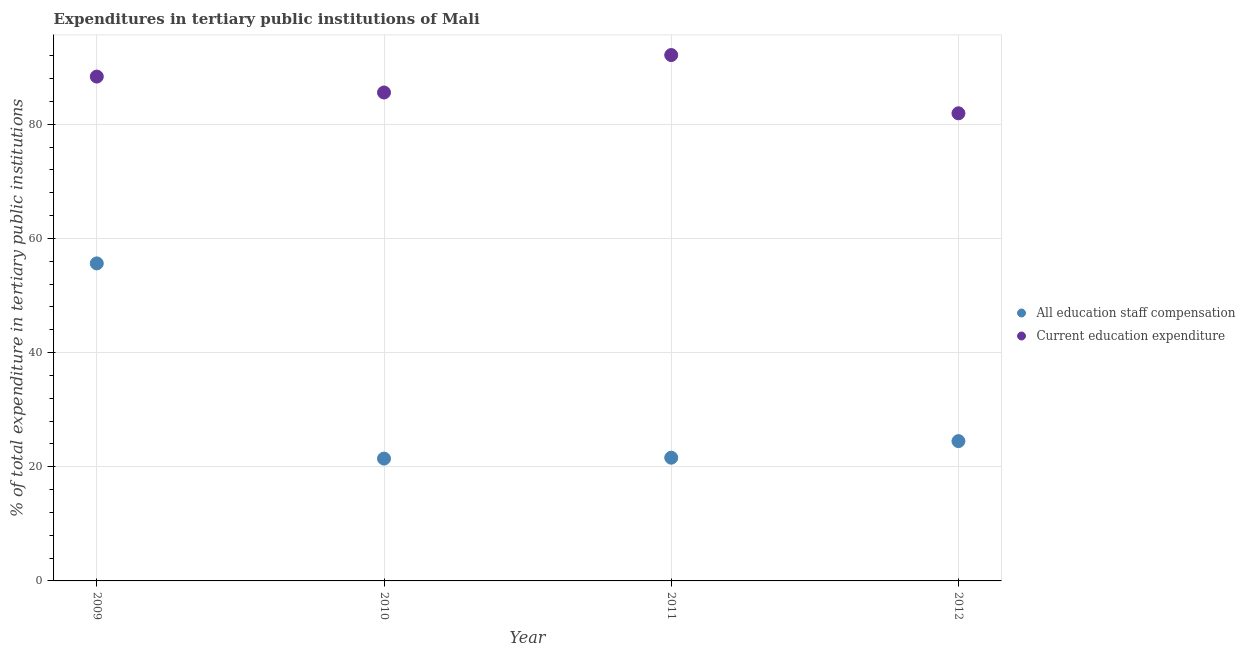How many different coloured dotlines are there?
Your response must be concise. 2. What is the expenditure in education in 2011?
Your answer should be very brief. 92.13. Across all years, what is the maximum expenditure in staff compensation?
Provide a succinct answer. 55.63. Across all years, what is the minimum expenditure in staff compensation?
Keep it short and to the point. 21.43. In which year was the expenditure in staff compensation maximum?
Ensure brevity in your answer.  2009. In which year was the expenditure in staff compensation minimum?
Your answer should be compact. 2010. What is the total expenditure in education in the graph?
Your answer should be compact. 347.98. What is the difference between the expenditure in education in 2009 and that in 2011?
Provide a succinct answer. -3.77. What is the difference between the expenditure in education in 2011 and the expenditure in staff compensation in 2009?
Keep it short and to the point. 36.5. What is the average expenditure in education per year?
Ensure brevity in your answer.  86.99. In the year 2011, what is the difference between the expenditure in staff compensation and expenditure in education?
Give a very brief answer. -70.54. What is the ratio of the expenditure in education in 2010 to that in 2011?
Offer a very short reply. 0.93. Is the difference between the expenditure in staff compensation in 2010 and 2012 greater than the difference between the expenditure in education in 2010 and 2012?
Offer a terse response. No. What is the difference between the highest and the second highest expenditure in education?
Offer a terse response. 3.77. What is the difference between the highest and the lowest expenditure in education?
Offer a terse response. 10.21. Does the expenditure in staff compensation monotonically increase over the years?
Your answer should be very brief. No. How many years are there in the graph?
Your answer should be compact. 4. Are the values on the major ticks of Y-axis written in scientific E-notation?
Offer a very short reply. No. Where does the legend appear in the graph?
Offer a very short reply. Center right. How many legend labels are there?
Your answer should be compact. 2. How are the legend labels stacked?
Provide a succinct answer. Vertical. What is the title of the graph?
Offer a very short reply. Expenditures in tertiary public institutions of Mali. What is the label or title of the Y-axis?
Keep it short and to the point. % of total expenditure in tertiary public institutions. What is the % of total expenditure in tertiary public institutions of All education staff compensation in 2009?
Your answer should be compact. 55.63. What is the % of total expenditure in tertiary public institutions of Current education expenditure in 2009?
Offer a terse response. 88.36. What is the % of total expenditure in tertiary public institutions in All education staff compensation in 2010?
Provide a short and direct response. 21.43. What is the % of total expenditure in tertiary public institutions in Current education expenditure in 2010?
Make the answer very short. 85.57. What is the % of total expenditure in tertiary public institutions of All education staff compensation in 2011?
Your answer should be compact. 21.59. What is the % of total expenditure in tertiary public institutions of Current education expenditure in 2011?
Offer a very short reply. 92.13. What is the % of total expenditure in tertiary public institutions of All education staff compensation in 2012?
Offer a terse response. 24.49. What is the % of total expenditure in tertiary public institutions of Current education expenditure in 2012?
Offer a very short reply. 81.92. Across all years, what is the maximum % of total expenditure in tertiary public institutions in All education staff compensation?
Provide a short and direct response. 55.63. Across all years, what is the maximum % of total expenditure in tertiary public institutions in Current education expenditure?
Provide a short and direct response. 92.13. Across all years, what is the minimum % of total expenditure in tertiary public institutions in All education staff compensation?
Provide a succinct answer. 21.43. Across all years, what is the minimum % of total expenditure in tertiary public institutions of Current education expenditure?
Offer a terse response. 81.92. What is the total % of total expenditure in tertiary public institutions of All education staff compensation in the graph?
Ensure brevity in your answer.  123.14. What is the total % of total expenditure in tertiary public institutions in Current education expenditure in the graph?
Offer a terse response. 347.98. What is the difference between the % of total expenditure in tertiary public institutions in All education staff compensation in 2009 and that in 2010?
Offer a very short reply. 34.2. What is the difference between the % of total expenditure in tertiary public institutions of Current education expenditure in 2009 and that in 2010?
Offer a terse response. 2.79. What is the difference between the % of total expenditure in tertiary public institutions in All education staff compensation in 2009 and that in 2011?
Your response must be concise. 34.04. What is the difference between the % of total expenditure in tertiary public institutions in Current education expenditure in 2009 and that in 2011?
Offer a terse response. -3.77. What is the difference between the % of total expenditure in tertiary public institutions of All education staff compensation in 2009 and that in 2012?
Your answer should be very brief. 31.14. What is the difference between the % of total expenditure in tertiary public institutions in Current education expenditure in 2009 and that in 2012?
Offer a terse response. 6.43. What is the difference between the % of total expenditure in tertiary public institutions of All education staff compensation in 2010 and that in 2011?
Make the answer very short. -0.16. What is the difference between the % of total expenditure in tertiary public institutions in Current education expenditure in 2010 and that in 2011?
Give a very brief answer. -6.56. What is the difference between the % of total expenditure in tertiary public institutions in All education staff compensation in 2010 and that in 2012?
Your answer should be compact. -3.06. What is the difference between the % of total expenditure in tertiary public institutions of Current education expenditure in 2010 and that in 2012?
Give a very brief answer. 3.65. What is the difference between the % of total expenditure in tertiary public institutions of All education staff compensation in 2011 and that in 2012?
Keep it short and to the point. -2.91. What is the difference between the % of total expenditure in tertiary public institutions of Current education expenditure in 2011 and that in 2012?
Make the answer very short. 10.21. What is the difference between the % of total expenditure in tertiary public institutions in All education staff compensation in 2009 and the % of total expenditure in tertiary public institutions in Current education expenditure in 2010?
Ensure brevity in your answer.  -29.94. What is the difference between the % of total expenditure in tertiary public institutions of All education staff compensation in 2009 and the % of total expenditure in tertiary public institutions of Current education expenditure in 2011?
Offer a very short reply. -36.5. What is the difference between the % of total expenditure in tertiary public institutions of All education staff compensation in 2009 and the % of total expenditure in tertiary public institutions of Current education expenditure in 2012?
Your response must be concise. -26.3. What is the difference between the % of total expenditure in tertiary public institutions in All education staff compensation in 2010 and the % of total expenditure in tertiary public institutions in Current education expenditure in 2011?
Make the answer very short. -70.7. What is the difference between the % of total expenditure in tertiary public institutions in All education staff compensation in 2010 and the % of total expenditure in tertiary public institutions in Current education expenditure in 2012?
Offer a terse response. -60.49. What is the difference between the % of total expenditure in tertiary public institutions in All education staff compensation in 2011 and the % of total expenditure in tertiary public institutions in Current education expenditure in 2012?
Provide a short and direct response. -60.34. What is the average % of total expenditure in tertiary public institutions in All education staff compensation per year?
Your answer should be very brief. 30.79. What is the average % of total expenditure in tertiary public institutions of Current education expenditure per year?
Ensure brevity in your answer.  86.99. In the year 2009, what is the difference between the % of total expenditure in tertiary public institutions of All education staff compensation and % of total expenditure in tertiary public institutions of Current education expenditure?
Keep it short and to the point. -32.73. In the year 2010, what is the difference between the % of total expenditure in tertiary public institutions in All education staff compensation and % of total expenditure in tertiary public institutions in Current education expenditure?
Give a very brief answer. -64.14. In the year 2011, what is the difference between the % of total expenditure in tertiary public institutions in All education staff compensation and % of total expenditure in tertiary public institutions in Current education expenditure?
Your answer should be compact. -70.54. In the year 2012, what is the difference between the % of total expenditure in tertiary public institutions in All education staff compensation and % of total expenditure in tertiary public institutions in Current education expenditure?
Provide a short and direct response. -57.43. What is the ratio of the % of total expenditure in tertiary public institutions in All education staff compensation in 2009 to that in 2010?
Keep it short and to the point. 2.6. What is the ratio of the % of total expenditure in tertiary public institutions in Current education expenditure in 2009 to that in 2010?
Ensure brevity in your answer.  1.03. What is the ratio of the % of total expenditure in tertiary public institutions in All education staff compensation in 2009 to that in 2011?
Provide a short and direct response. 2.58. What is the ratio of the % of total expenditure in tertiary public institutions of Current education expenditure in 2009 to that in 2011?
Your answer should be compact. 0.96. What is the ratio of the % of total expenditure in tertiary public institutions of All education staff compensation in 2009 to that in 2012?
Ensure brevity in your answer.  2.27. What is the ratio of the % of total expenditure in tertiary public institutions in Current education expenditure in 2009 to that in 2012?
Provide a short and direct response. 1.08. What is the ratio of the % of total expenditure in tertiary public institutions in All education staff compensation in 2010 to that in 2011?
Provide a short and direct response. 0.99. What is the ratio of the % of total expenditure in tertiary public institutions in Current education expenditure in 2010 to that in 2011?
Offer a very short reply. 0.93. What is the ratio of the % of total expenditure in tertiary public institutions in All education staff compensation in 2010 to that in 2012?
Give a very brief answer. 0.88. What is the ratio of the % of total expenditure in tertiary public institutions of Current education expenditure in 2010 to that in 2012?
Make the answer very short. 1.04. What is the ratio of the % of total expenditure in tertiary public institutions of All education staff compensation in 2011 to that in 2012?
Your answer should be compact. 0.88. What is the ratio of the % of total expenditure in tertiary public institutions of Current education expenditure in 2011 to that in 2012?
Your answer should be very brief. 1.12. What is the difference between the highest and the second highest % of total expenditure in tertiary public institutions in All education staff compensation?
Keep it short and to the point. 31.14. What is the difference between the highest and the second highest % of total expenditure in tertiary public institutions in Current education expenditure?
Make the answer very short. 3.77. What is the difference between the highest and the lowest % of total expenditure in tertiary public institutions of All education staff compensation?
Your answer should be very brief. 34.2. What is the difference between the highest and the lowest % of total expenditure in tertiary public institutions of Current education expenditure?
Provide a succinct answer. 10.21. 